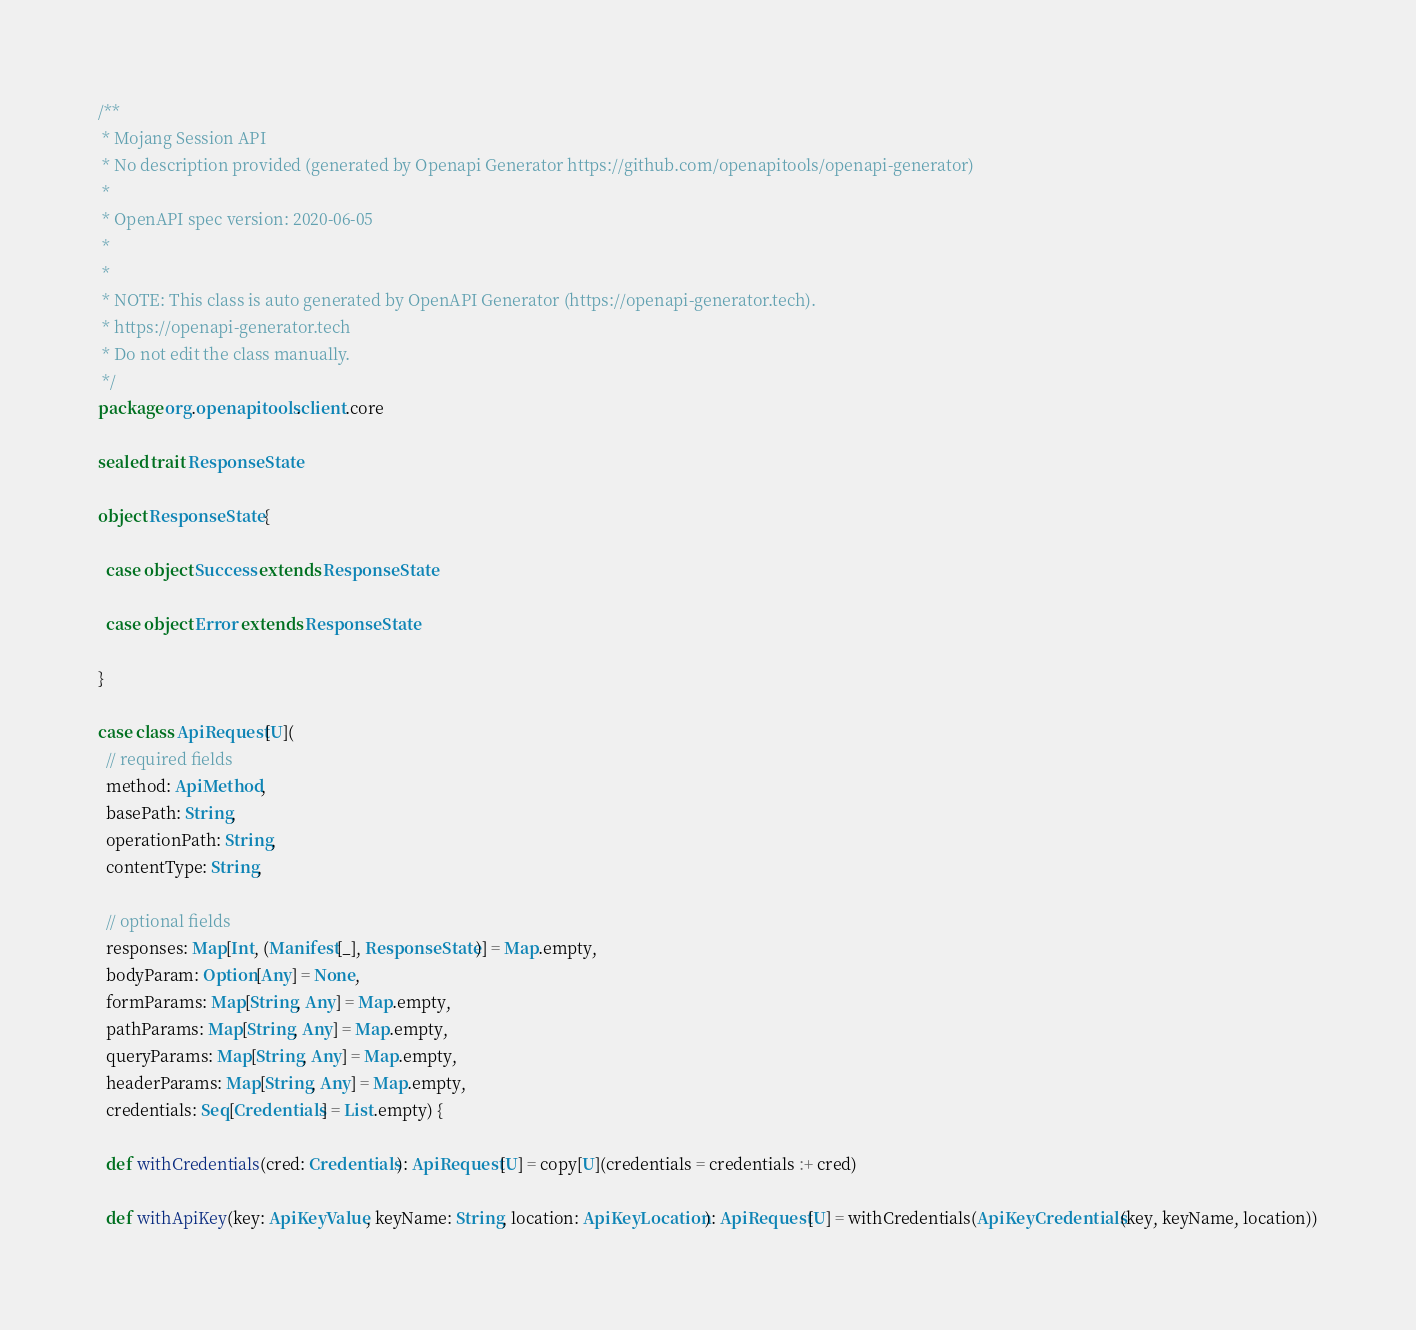Convert code to text. <code><loc_0><loc_0><loc_500><loc_500><_Scala_>/**
 * Mojang Session API
 * No description provided (generated by Openapi Generator https://github.com/openapitools/openapi-generator)
 *
 * OpenAPI spec version: 2020-06-05
 * 
 *
 * NOTE: This class is auto generated by OpenAPI Generator (https://openapi-generator.tech).
 * https://openapi-generator.tech
 * Do not edit the class manually.
 */
package org.openapitools.client.core

sealed trait ResponseState

object ResponseState {

  case object Success extends ResponseState

  case object Error extends ResponseState

}

case class ApiRequest[U](
  // required fields
  method: ApiMethod,
  basePath: String,
  operationPath: String,
  contentType: String,

  // optional fields
  responses: Map[Int, (Manifest[_], ResponseState)] = Map.empty,
  bodyParam: Option[Any] = None,
  formParams: Map[String, Any] = Map.empty,
  pathParams: Map[String, Any] = Map.empty,
  queryParams: Map[String, Any] = Map.empty,
  headerParams: Map[String, Any] = Map.empty,
  credentials: Seq[Credentials] = List.empty) {

  def withCredentials(cred: Credentials): ApiRequest[U] = copy[U](credentials = credentials :+ cred)

  def withApiKey(key: ApiKeyValue, keyName: String, location: ApiKeyLocation): ApiRequest[U] = withCredentials(ApiKeyCredentials(key, keyName, location))
</code> 